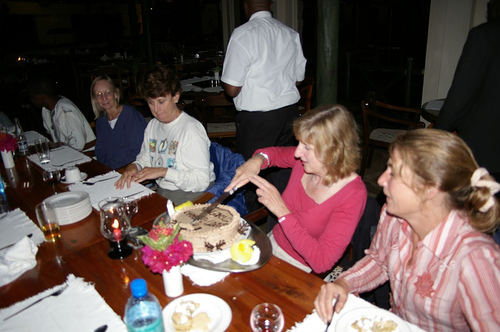<image>What holiday are these people celebrating in their house? I don't know what holiday these people are celebrating in their house. It could potentially be a birthday or a work party. What holiday are these people celebrating in their house? I am not sure what holiday these people are celebrating in their house. It can be birthday or thanksgiving. 